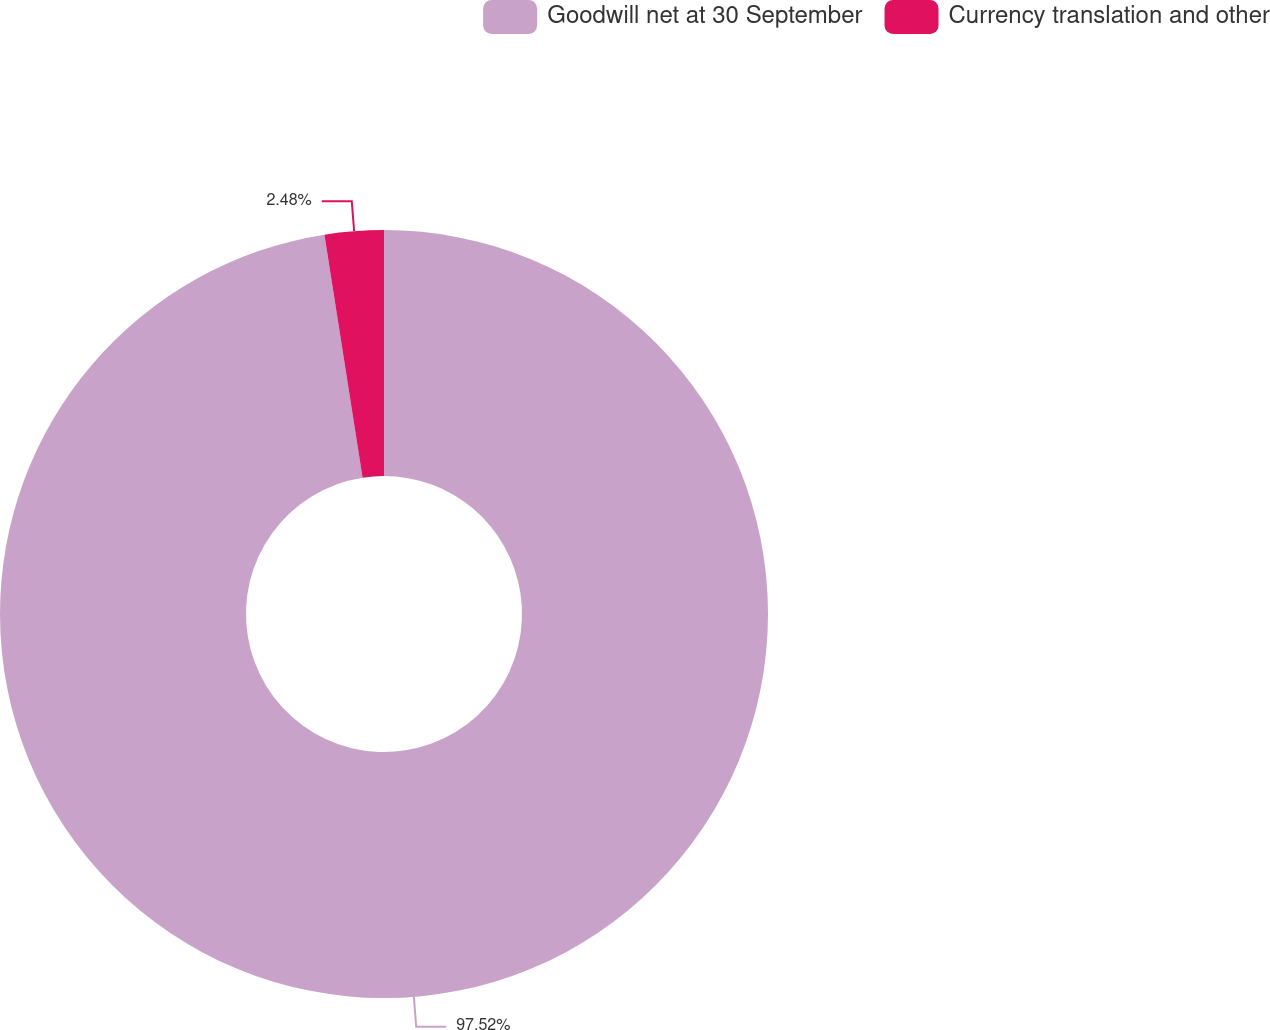Convert chart. <chart><loc_0><loc_0><loc_500><loc_500><pie_chart><fcel>Goodwill net at 30 September<fcel>Currency translation and other<nl><fcel>97.52%<fcel>2.48%<nl></chart> 